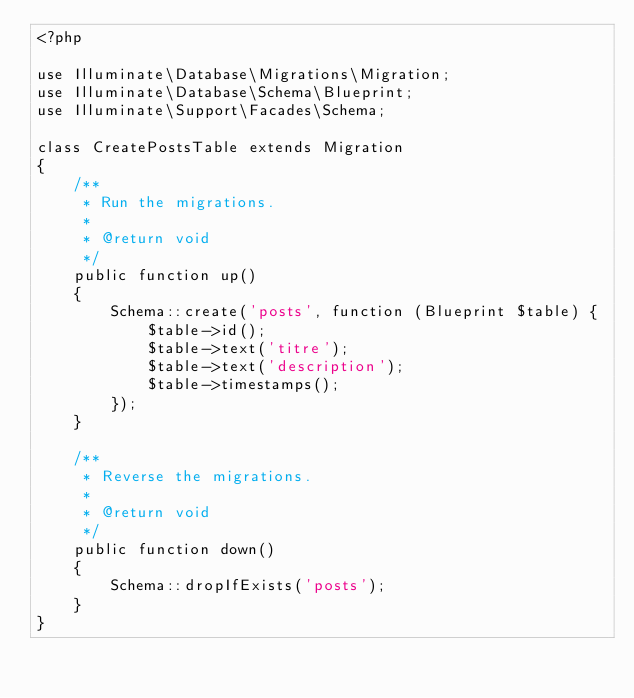Convert code to text. <code><loc_0><loc_0><loc_500><loc_500><_PHP_><?php

use Illuminate\Database\Migrations\Migration;
use Illuminate\Database\Schema\Blueprint;
use Illuminate\Support\Facades\Schema;

class CreatePostsTable extends Migration
{
    /**
     * Run the migrations.
     *
     * @return void
     */
    public function up()
    {
        Schema::create('posts', function (Blueprint $table) {
            $table->id();
            $table->text('titre');
            $table->text('description');
            $table->timestamps();
        });
    }

    /**
     * Reverse the migrations.
     *
     * @return void
     */
    public function down()
    {
        Schema::dropIfExists('posts');
    }
}
</code> 